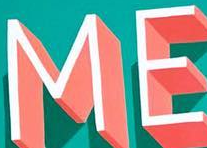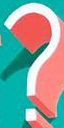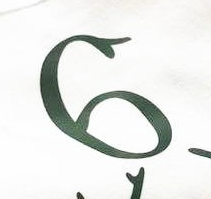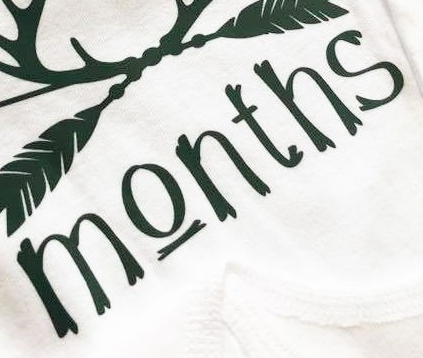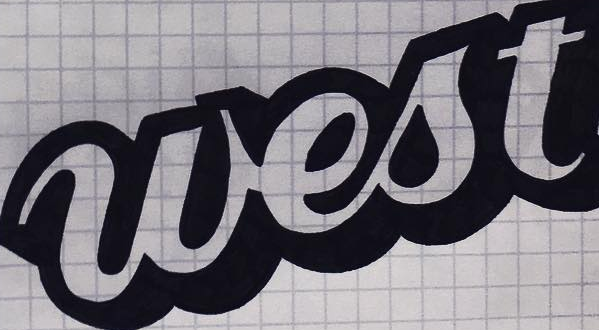Read the text from these images in sequence, separated by a semicolon. ME; ?; 6; Months; west 